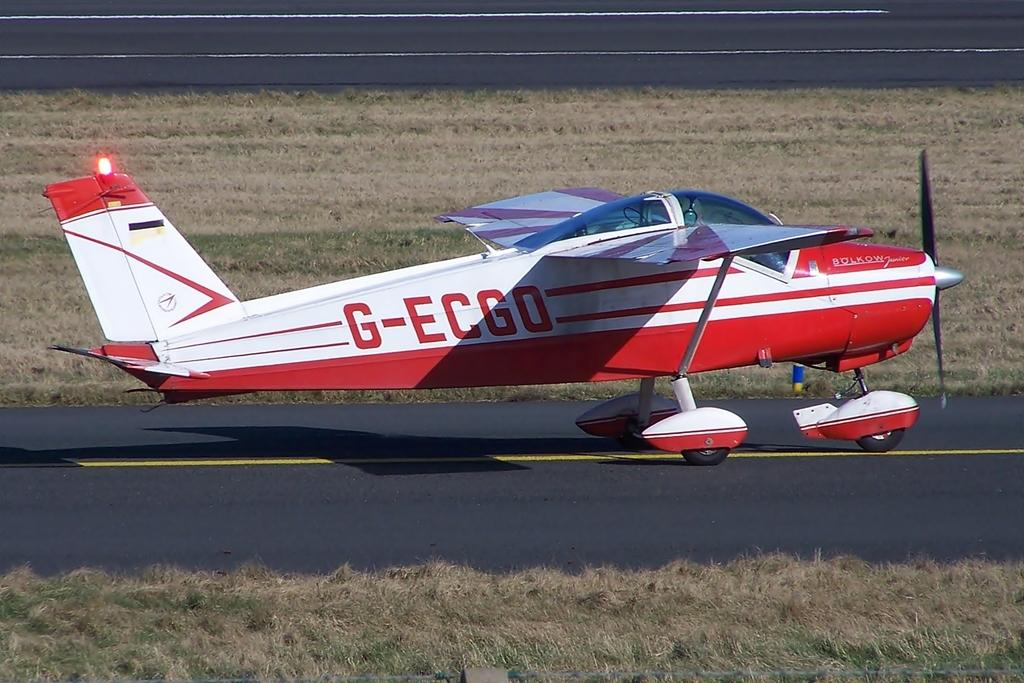Provide a one-sentence caption for the provided image. a private plane with the letters G-ECGO is sitting on the tarmack. 